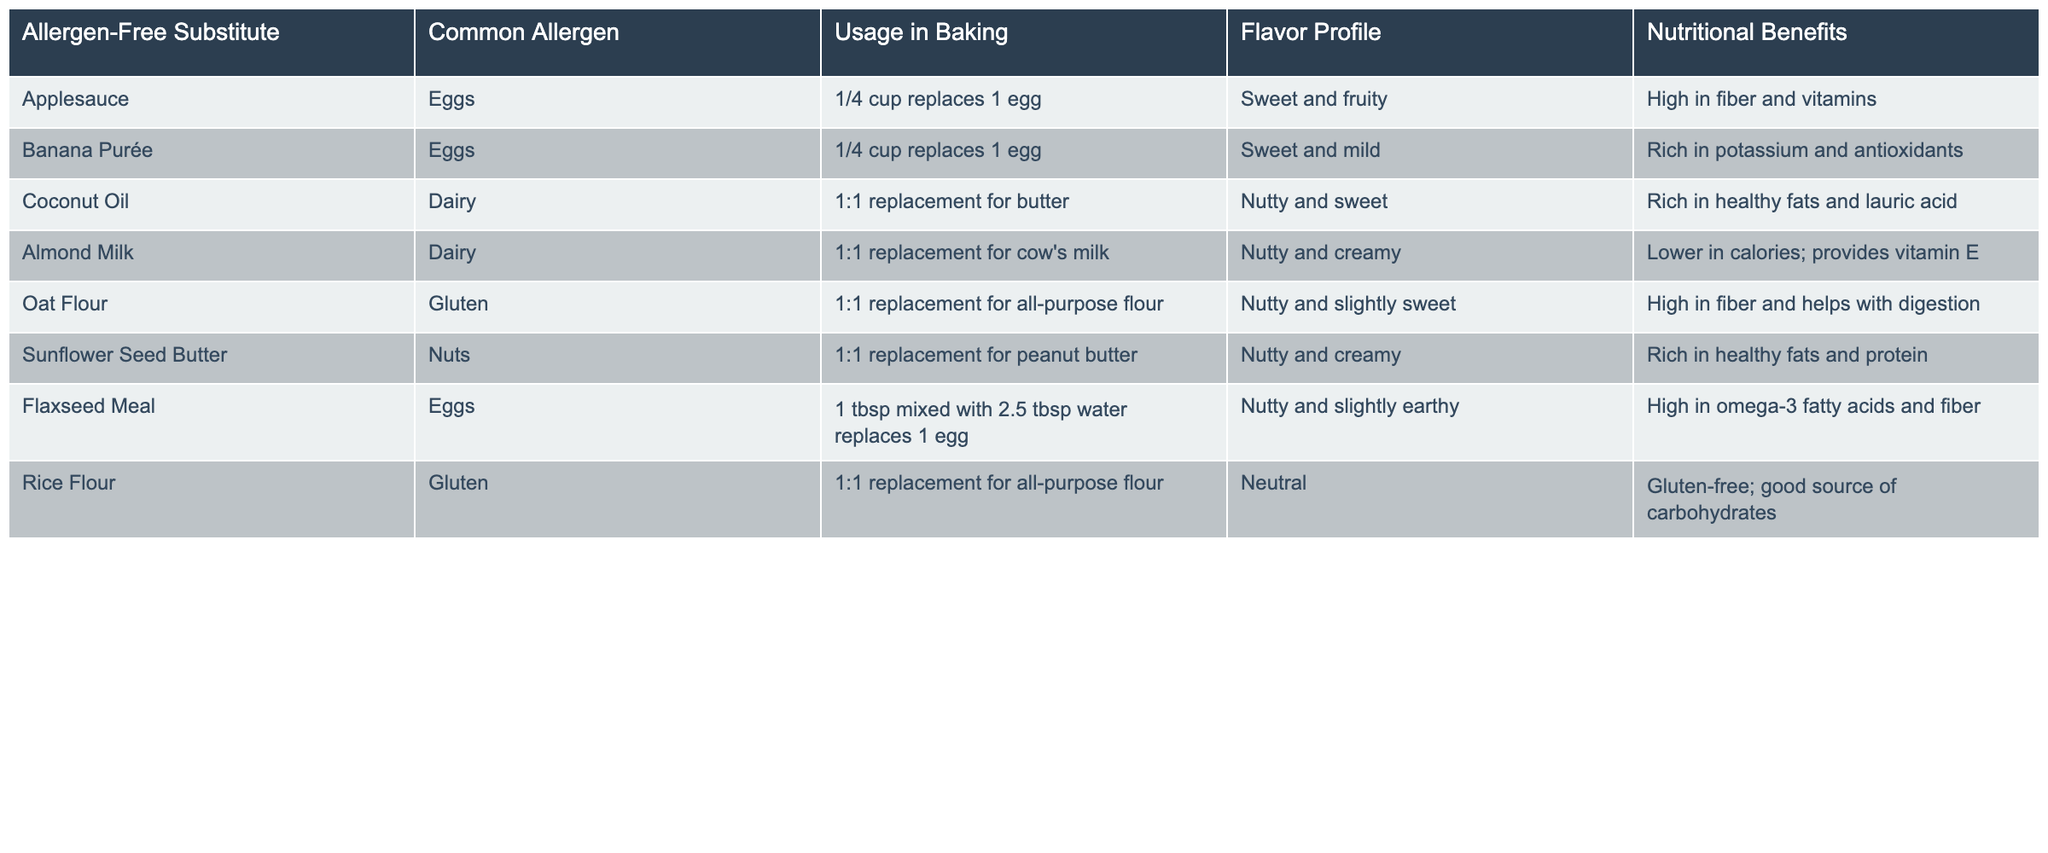What is the flavor profile of Applesauce? According to the table, the flavor profile listed for Applesauce is "Sweet and fruity."
Answer: Sweet and fruity Which allergen-free substitute replaces 1 egg and is high in fiber and vitamins? The table states that Applesauce can replace 1 egg and is high in fiber and vitamins.
Answer: Applesauce Is Coconut Oil a gluten-free substitute? The table does not list Coconut Oil as containing gluten, indicating that it is gluten-free.
Answer: Yes What are the nutritional benefits of Flaxseed Meal? The table indicates that Flaxseed Meal is high in omega-3 fatty acids and fiber.
Answer: High in omega-3 fatty acids and fiber How many different allergens does Banana Purée replace in this table? Banana Purée specifically replaces Eggs in the table, so it addresses one common allergen.
Answer: One Which allergen has the most substitutes listed in the table? By reviewing the table entries, it looks like the most substitutes relate to Eggs, with both Applesauce and Flaxseed Meal listed.
Answer: Eggs What is the usage recommendation for Oat Flour in children's recipes? The table indicates that Oat Flour is a 1:1 replacement for all-purpose flour in baking.
Answer: 1:1 replacement for all-purpose flour If you combine the nutritional benefits of Almond Milk and Coconut Oil, what major benefit do you get? Almond Milk is lower in calories and provides vitamin E, while Coconut Oil is rich in healthy fats; combined, these offer a balance of healthy fats and vitamins.
Answer: Healthy fats and vitamins Which substitutes have a nutty flavor profile? The table lists Coconut Oil, Oat Flour, and Sunflower Seed Butter with a nutty flavor profile.
Answer: Coconut Oil, Oat Flour, Sunflower Seed Butter What is the replacement ratio of Rice Flour for all-purpose flour? Rice Flour is indicated in the table as a 1:1 replacement for all-purpose flour, just like Oat Flour.
Answer: 1:1 replacement for all-purpose flour 